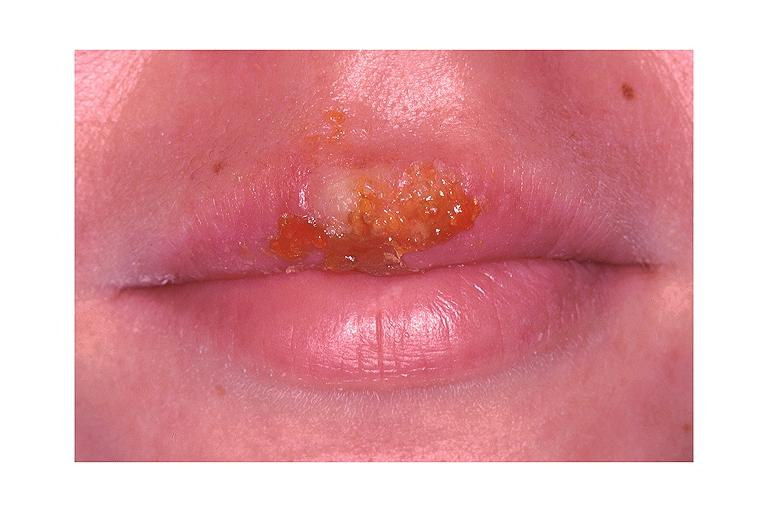s oral present?
Answer the question using a single word or phrase. Yes 